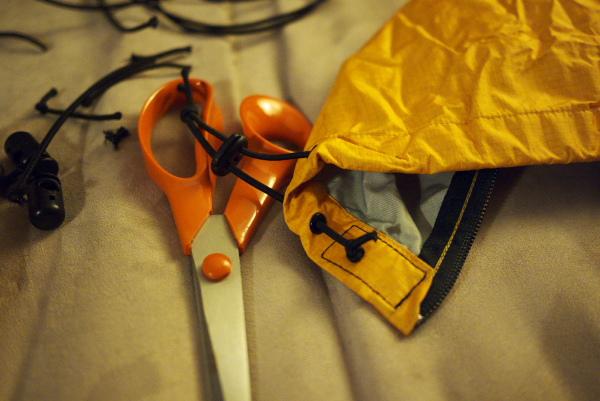What are the color of the handles on the scissors?
Answer briefly. Orange. What color is the clothing in the picture?
Short answer required. Yellow. Is there a sewing machine in the picture?
Keep it brief. No. 